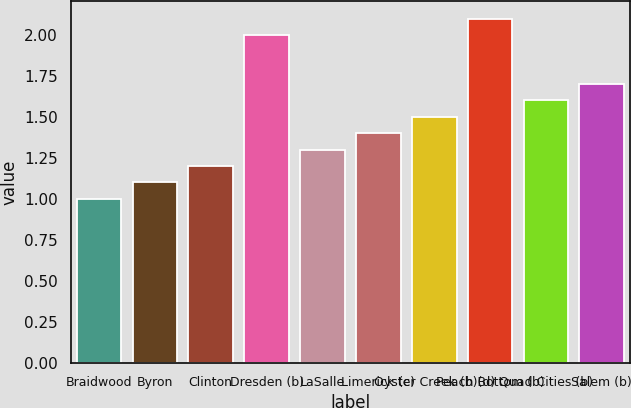Convert chart to OTSL. <chart><loc_0><loc_0><loc_500><loc_500><bar_chart><fcel>Braidwood<fcel>Byron<fcel>Clinton<fcel>Dresden (b)<fcel>LaSalle<fcel>Limerick (c)<fcel>Oyster Creek (b)(d)<fcel>Peach Bottom (b)<fcel>Quad Cities (b)<fcel>Salem (b)<nl><fcel>1<fcel>1.1<fcel>1.2<fcel>2<fcel>1.3<fcel>1.4<fcel>1.5<fcel>2.1<fcel>1.6<fcel>1.7<nl></chart> 